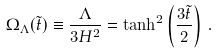<formula> <loc_0><loc_0><loc_500><loc_500>\Omega _ { \Lambda } ( { \tilde { t } } ) \equiv \frac { \Lambda } { 3 H ^ { 2 } } = \tanh ^ { 2 } \left ( \frac { 3 \tilde { t } } { 2 } \right ) \, .</formula> 